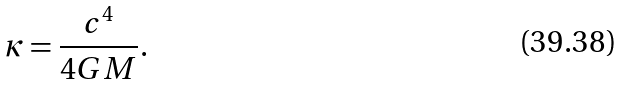Convert formula to latex. <formula><loc_0><loc_0><loc_500><loc_500>\kappa = \frac { c ^ { 4 } } { 4 G M } .</formula> 